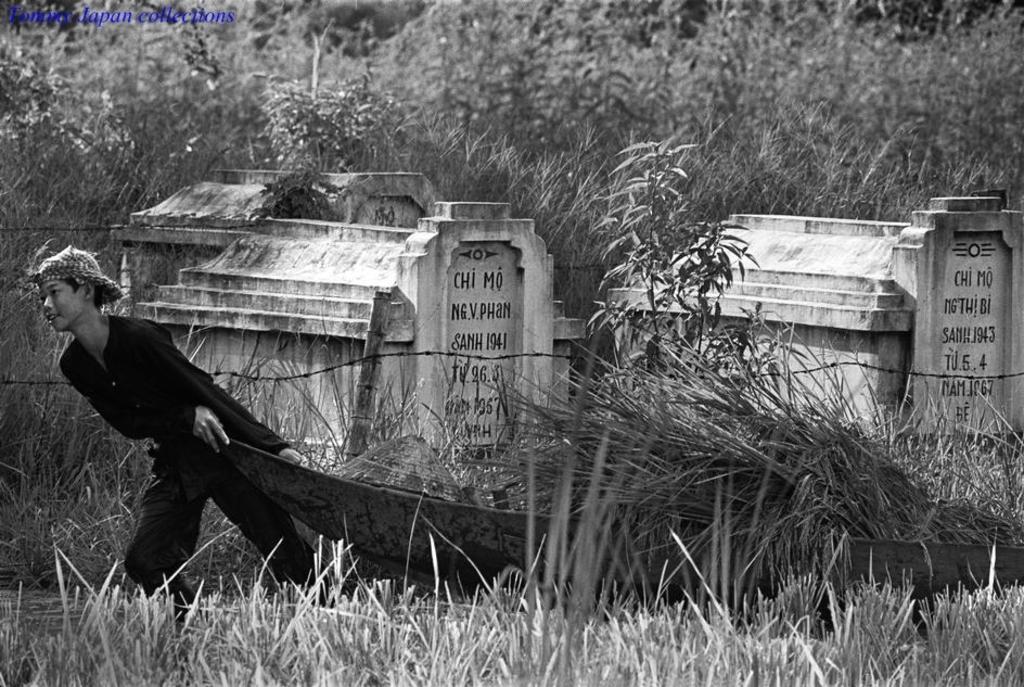In one or two sentences, can you explain what this image depicts? In this black and white picture we can see a boy dragging something on the ground. We can see grass, plants and tombstones with fencing. 